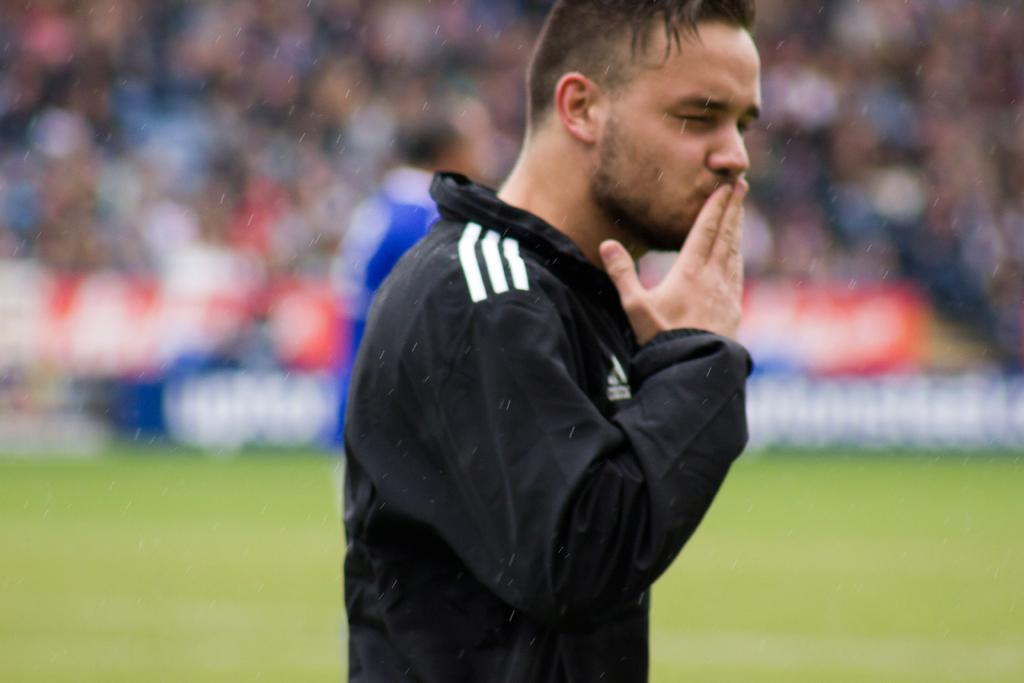What is the main subject of the image? There is a person standing in the middle of the image. What is the person wearing in the image? The person is wearing a black color jacket. What can be seen in the background of the image? There appears to be a crowd in the background of the image. How many stitches are visible on the person's jacket in the image? There is no information about the stitches on the person's jacket in the image, so it cannot be determined. Can you see any mice running around in the image? There are no mice present in the image. 